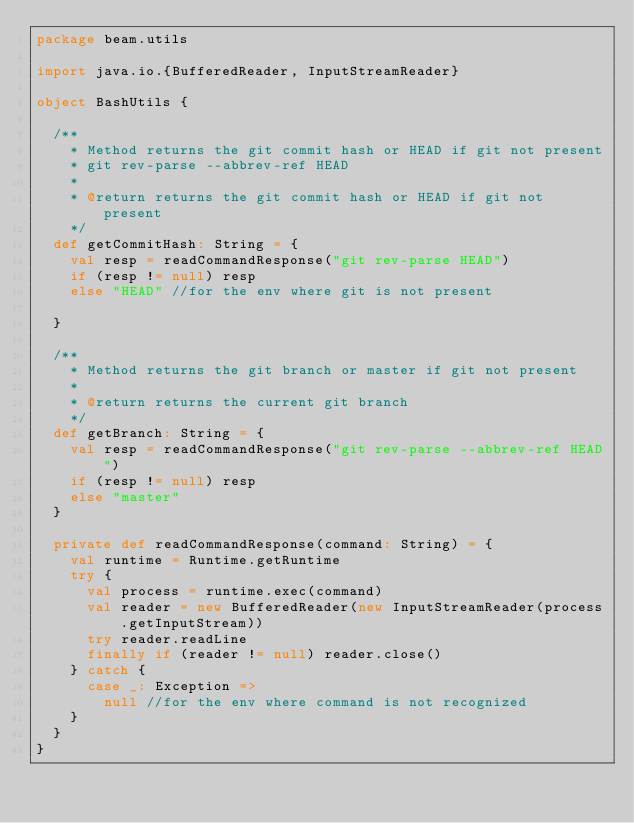Convert code to text. <code><loc_0><loc_0><loc_500><loc_500><_Scala_>package beam.utils

import java.io.{BufferedReader, InputStreamReader}

object BashUtils {

  /**
    * Method returns the git commit hash or HEAD if git not present
    * git rev-parse --abbrev-ref HEAD
    *
    * @return returns the git commit hash or HEAD if git not present
    */
  def getCommitHash: String = {
    val resp = readCommandResponse("git rev-parse HEAD")
    if (resp != null) resp
    else "HEAD" //for the env where git is not present

  }

  /**
    * Method returns the git branch or master if git not present
    *
    * @return returns the current git branch
    */
  def getBranch: String = {
    val resp = readCommandResponse("git rev-parse --abbrev-ref HEAD")
    if (resp != null) resp
    else "master"
  }

  private def readCommandResponse(command: String) = {
    val runtime = Runtime.getRuntime
    try {
      val process = runtime.exec(command)
      val reader = new BufferedReader(new InputStreamReader(process.getInputStream))
      try reader.readLine
      finally if (reader != null) reader.close()
    } catch {
      case _: Exception =>
        null //for the env where command is not recognized
    }
  }
}
</code> 